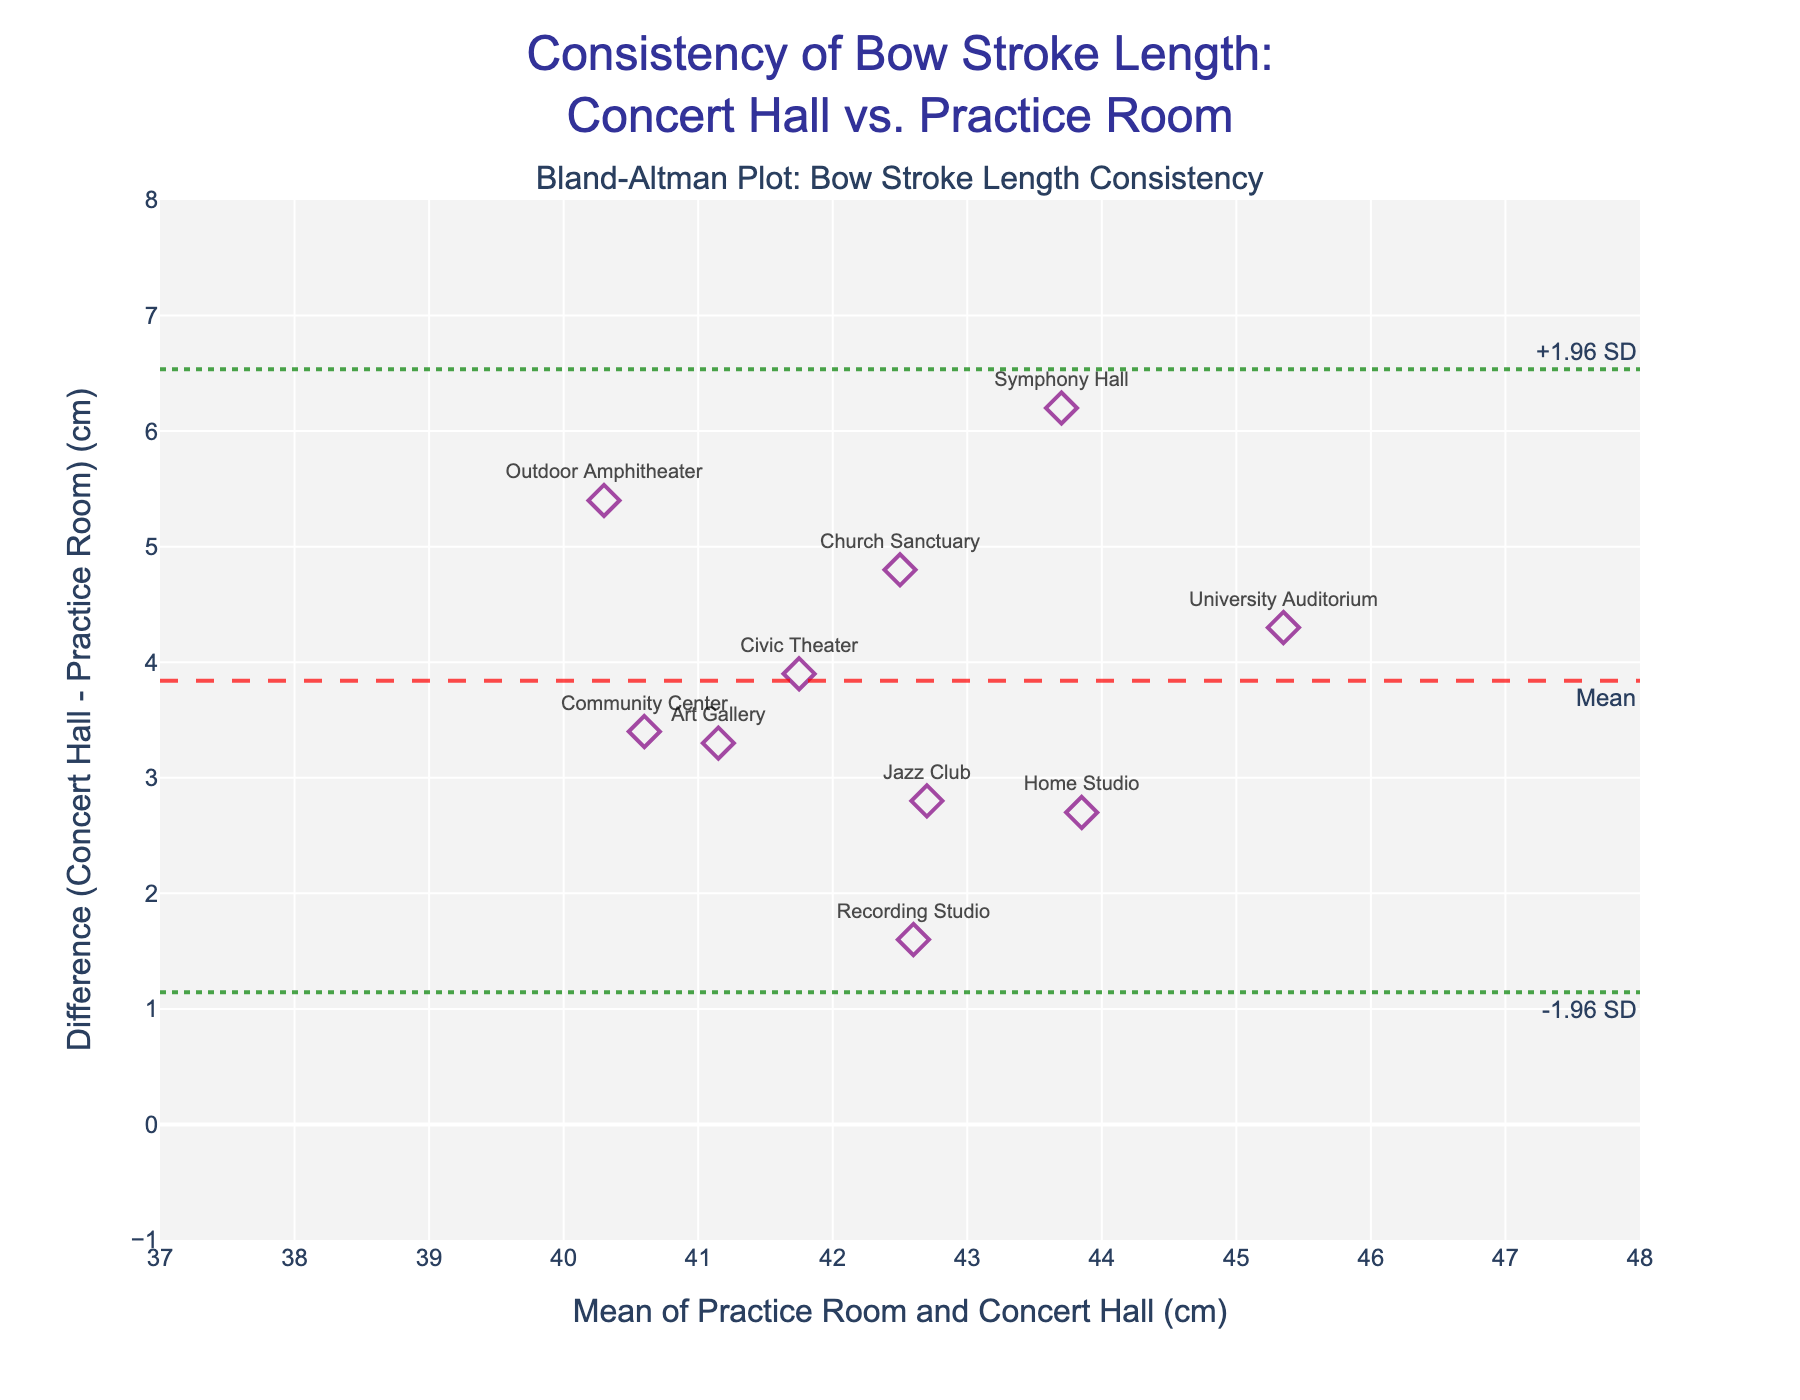which venue has the largest difference in bow stroke length between the practice room and the concert hall? Identify the largest positive y-value on the plot. The Symphony Hall has the highest value of approximately +6.2 cm.
Answer: Symphony Hall what is the mean difference in bow stroke length between the practice room and the concert hall? Look for the dashed red horizontal line annotated "Mean" on the plot. This indicates the mean difference in bow stroke length.
Answer: ~4.23 cm between which values do most of the differences fall? The limits of agreement (LoA) are marked by dotted green lines on the plot at approximately -0.46 and +8.92 cm. Most data points fall within this range.
Answer: -0.46 to 8.92 cm what is the difference in bow stroke length for Civic Theater? Locate the Civic Theater label on the diamond marker and note the associated y-value, approximately +3.9 cm.
Answer: ~3.9 cm are there any venues where the bow stroke length in the concert hall is shorter than in the practice room? Check if any points fall below the zero line (y = 0) on the Bland-Altman plot. There are no markers below this line.
Answer: No what does the Bland-Altman plot indicate about the overall consistency of bow stroke length in different environments? The mean difference line above zero suggests there is a consistent increase in bow stroke length when moving from practice room to concert hall. The LoA shows how scores vary around this mean.
Answer: Consistently longer in concert hall how many venues have a bow stroke length difference greater than 4 cm when moving from the practice room to the concert hall? Count the number of data points above the y = 4 cm line. There are 4 points.
Answer: 4 which venues have the smallest and largest mean bow stroke lengths? The x-axis shows the mean bow stroke lengths. Locate the furthest left and right markers: Outdoor Amphitheater (~40.3 cm) and University Auditorium (~45.35 cm) respectively.
Answer: Outdoor Amphitheater and University Auditorium how does the variability in bow stroke length differences compare to the mean difference? Compare the spread of data points to the mean difference line. The range given by the limits of agreement, from approximately -0.46 cm to +8.92 cm, indicates moderate variability around the mean of ~4.23 cm.
Answer: Moderate variability around mean 